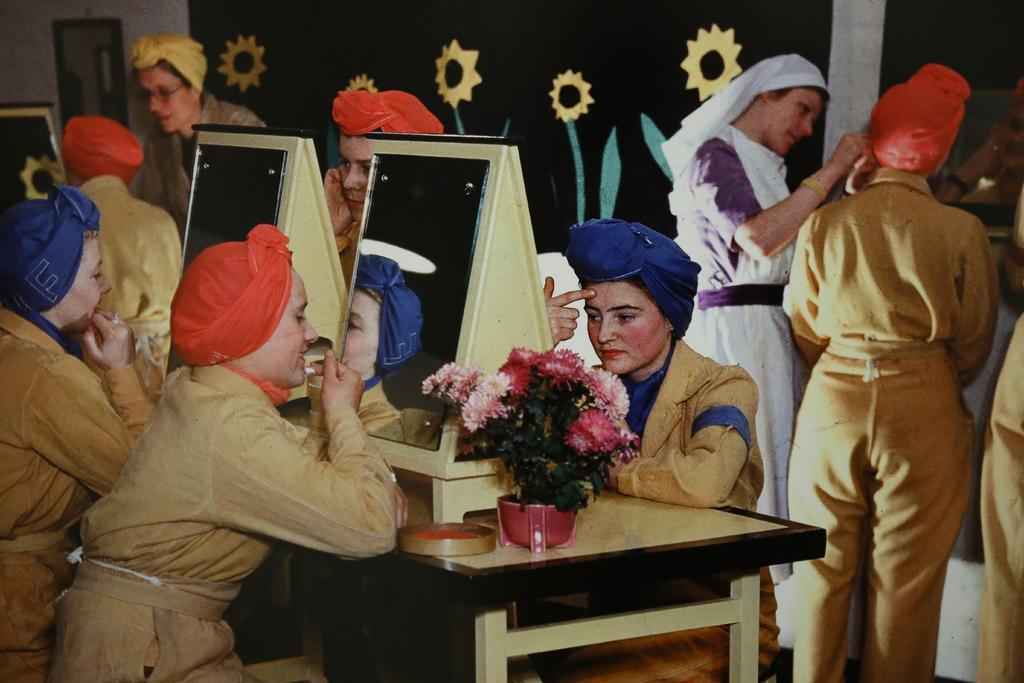Describe this image in one or two sentences. In this picture there are three persons who are sitting on a chair. There are two mirrors, a flower pot and a plant , round object is seen on the table. Few people are standing to the right side and two people are standing to the left side. A black curtain and a flower is seen on the curtain. 